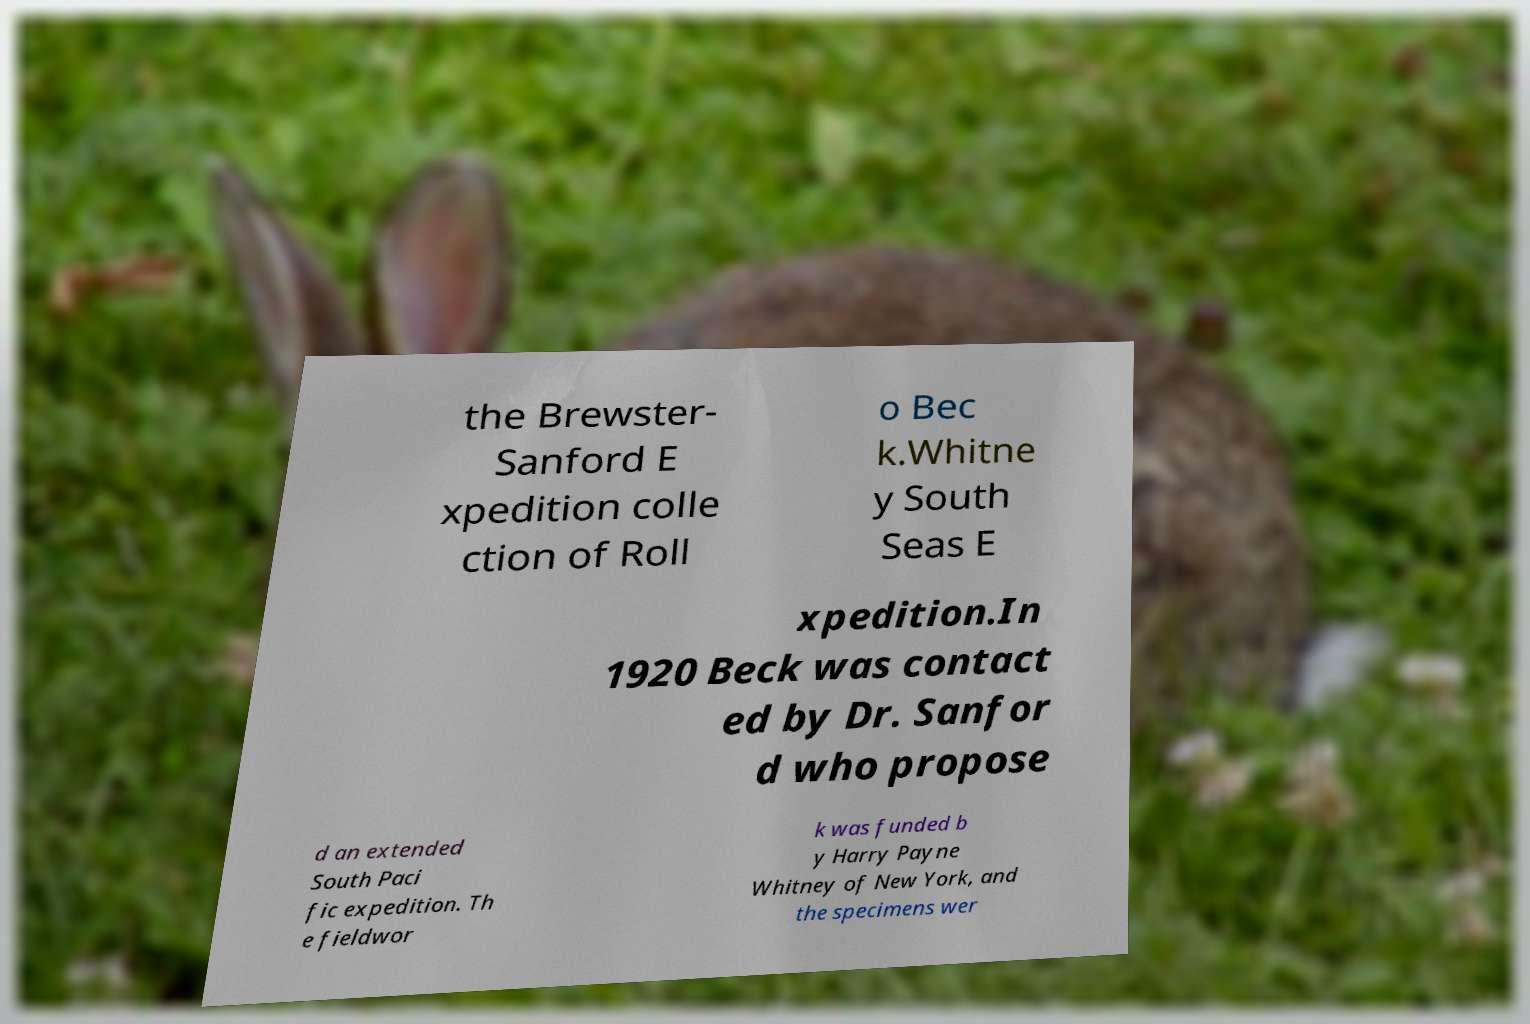Can you accurately transcribe the text from the provided image for me? the Brewster- Sanford E xpedition colle ction of Roll o Bec k.Whitne y South Seas E xpedition.In 1920 Beck was contact ed by Dr. Sanfor d who propose d an extended South Paci fic expedition. Th e fieldwor k was funded b y Harry Payne Whitney of New York, and the specimens wer 